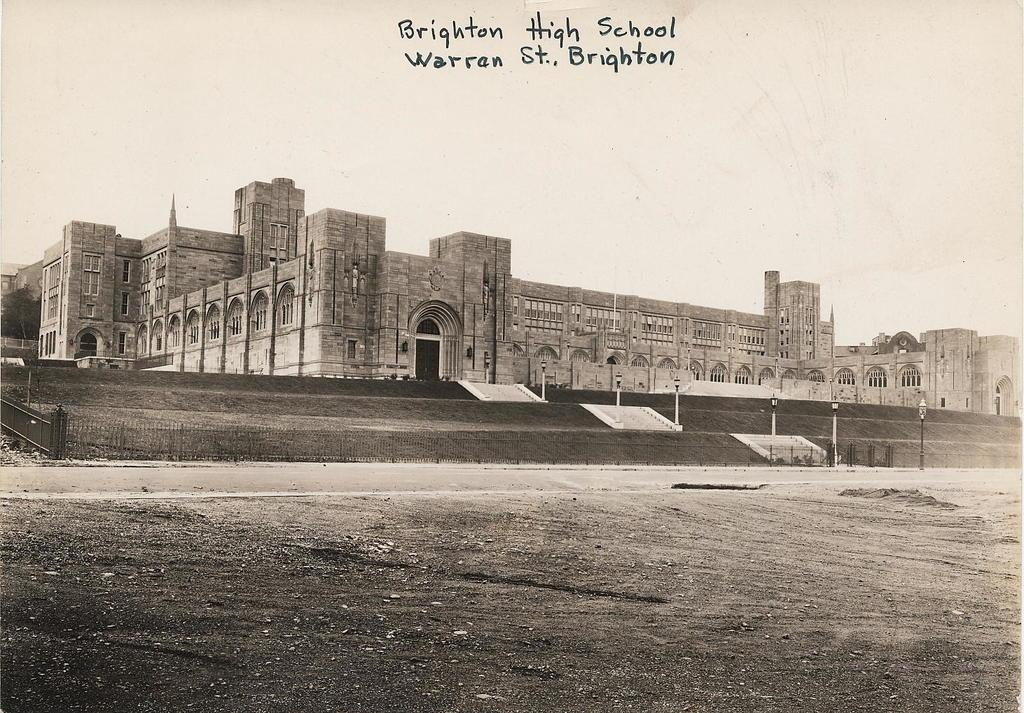<image>
Relay a brief, clear account of the picture shown. an old picture of Brighten High School Warren St. Brighton 